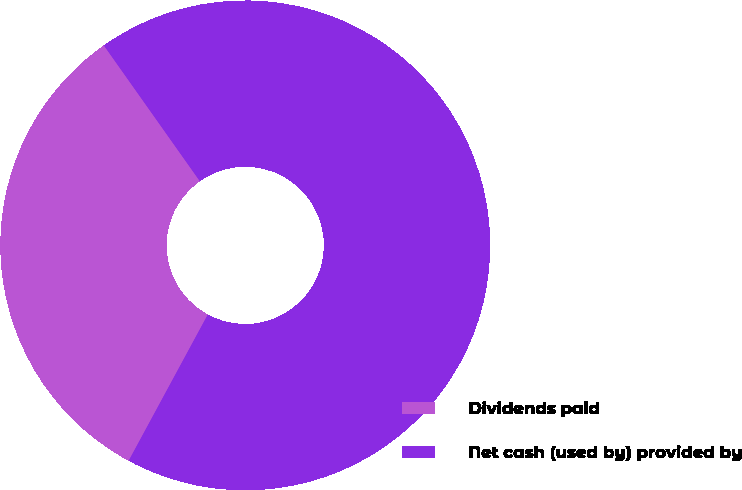<chart> <loc_0><loc_0><loc_500><loc_500><pie_chart><fcel>Dividends paid<fcel>Net cash (used by) provided by<nl><fcel>32.31%<fcel>67.69%<nl></chart> 